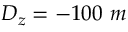<formula> <loc_0><loc_0><loc_500><loc_500>D _ { z } = - 1 0 0 m</formula> 